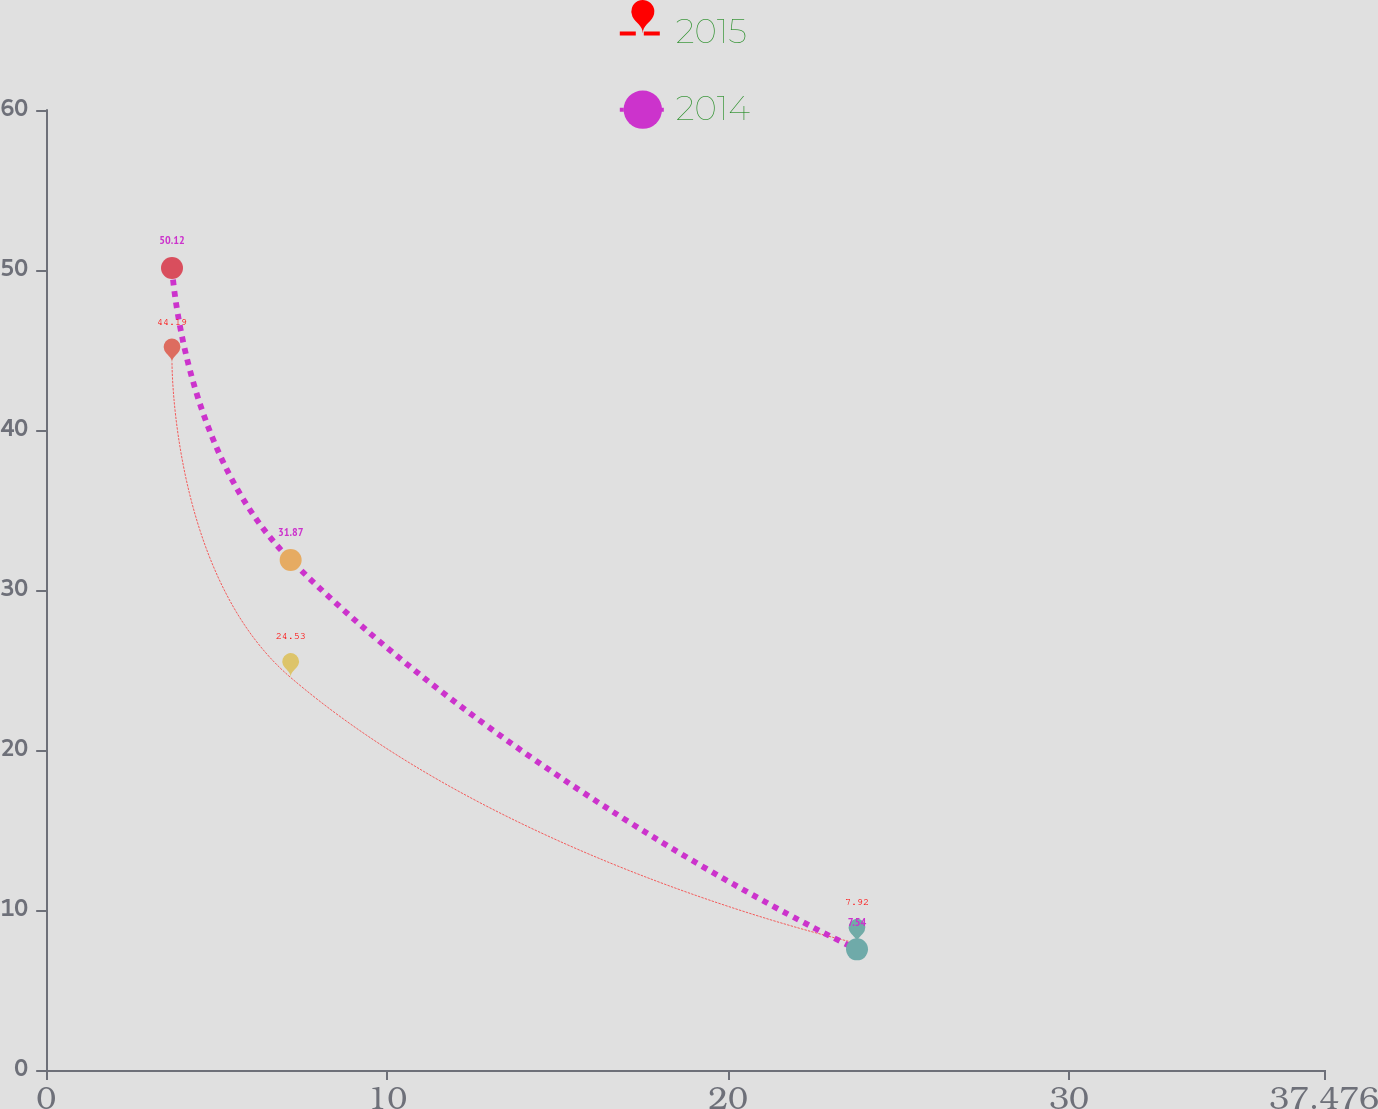<chart> <loc_0><loc_0><loc_500><loc_500><line_chart><ecel><fcel>2015<fcel>2014<nl><fcel>3.69<fcel>44.19<fcel>50.12<nl><fcel>7.17<fcel>24.53<fcel>31.87<nl><fcel>23.78<fcel>7.92<fcel>7.54<nl><fcel>37.75<fcel>3.59<fcel>2.81<nl><fcel>41.23<fcel>40.49<fcel>44.81<nl></chart> 